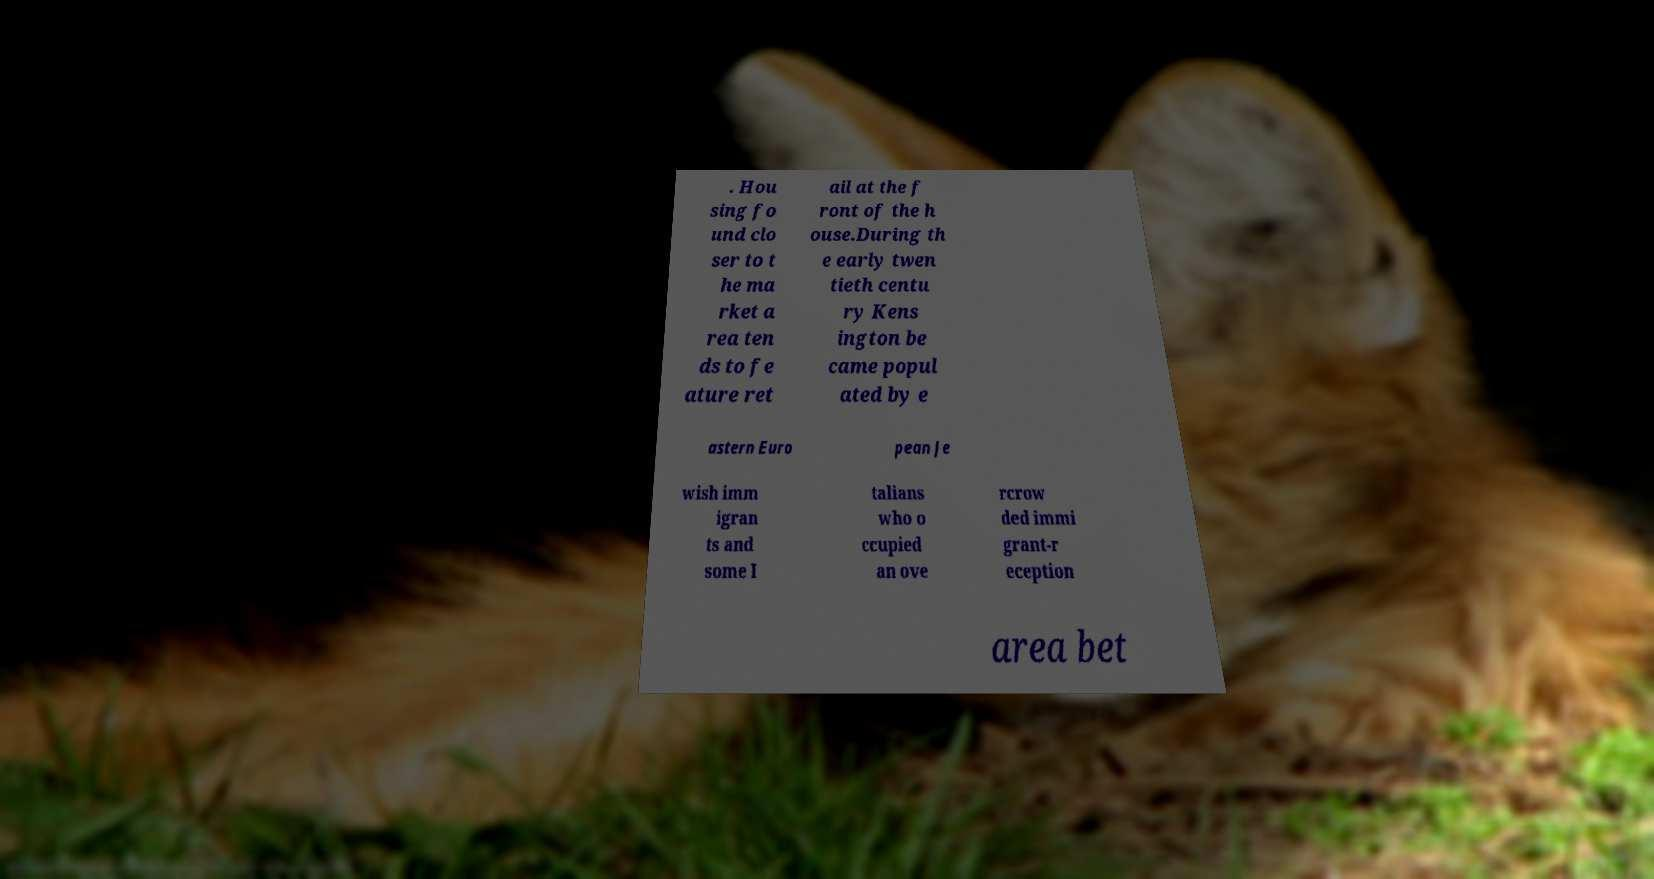Can you read and provide the text displayed in the image?This photo seems to have some interesting text. Can you extract and type it out for me? . Hou sing fo und clo ser to t he ma rket a rea ten ds to fe ature ret ail at the f ront of the h ouse.During th e early twen tieth centu ry Kens ington be came popul ated by e astern Euro pean Je wish imm igran ts and some I talians who o ccupied an ove rcrow ded immi grant-r eception area bet 